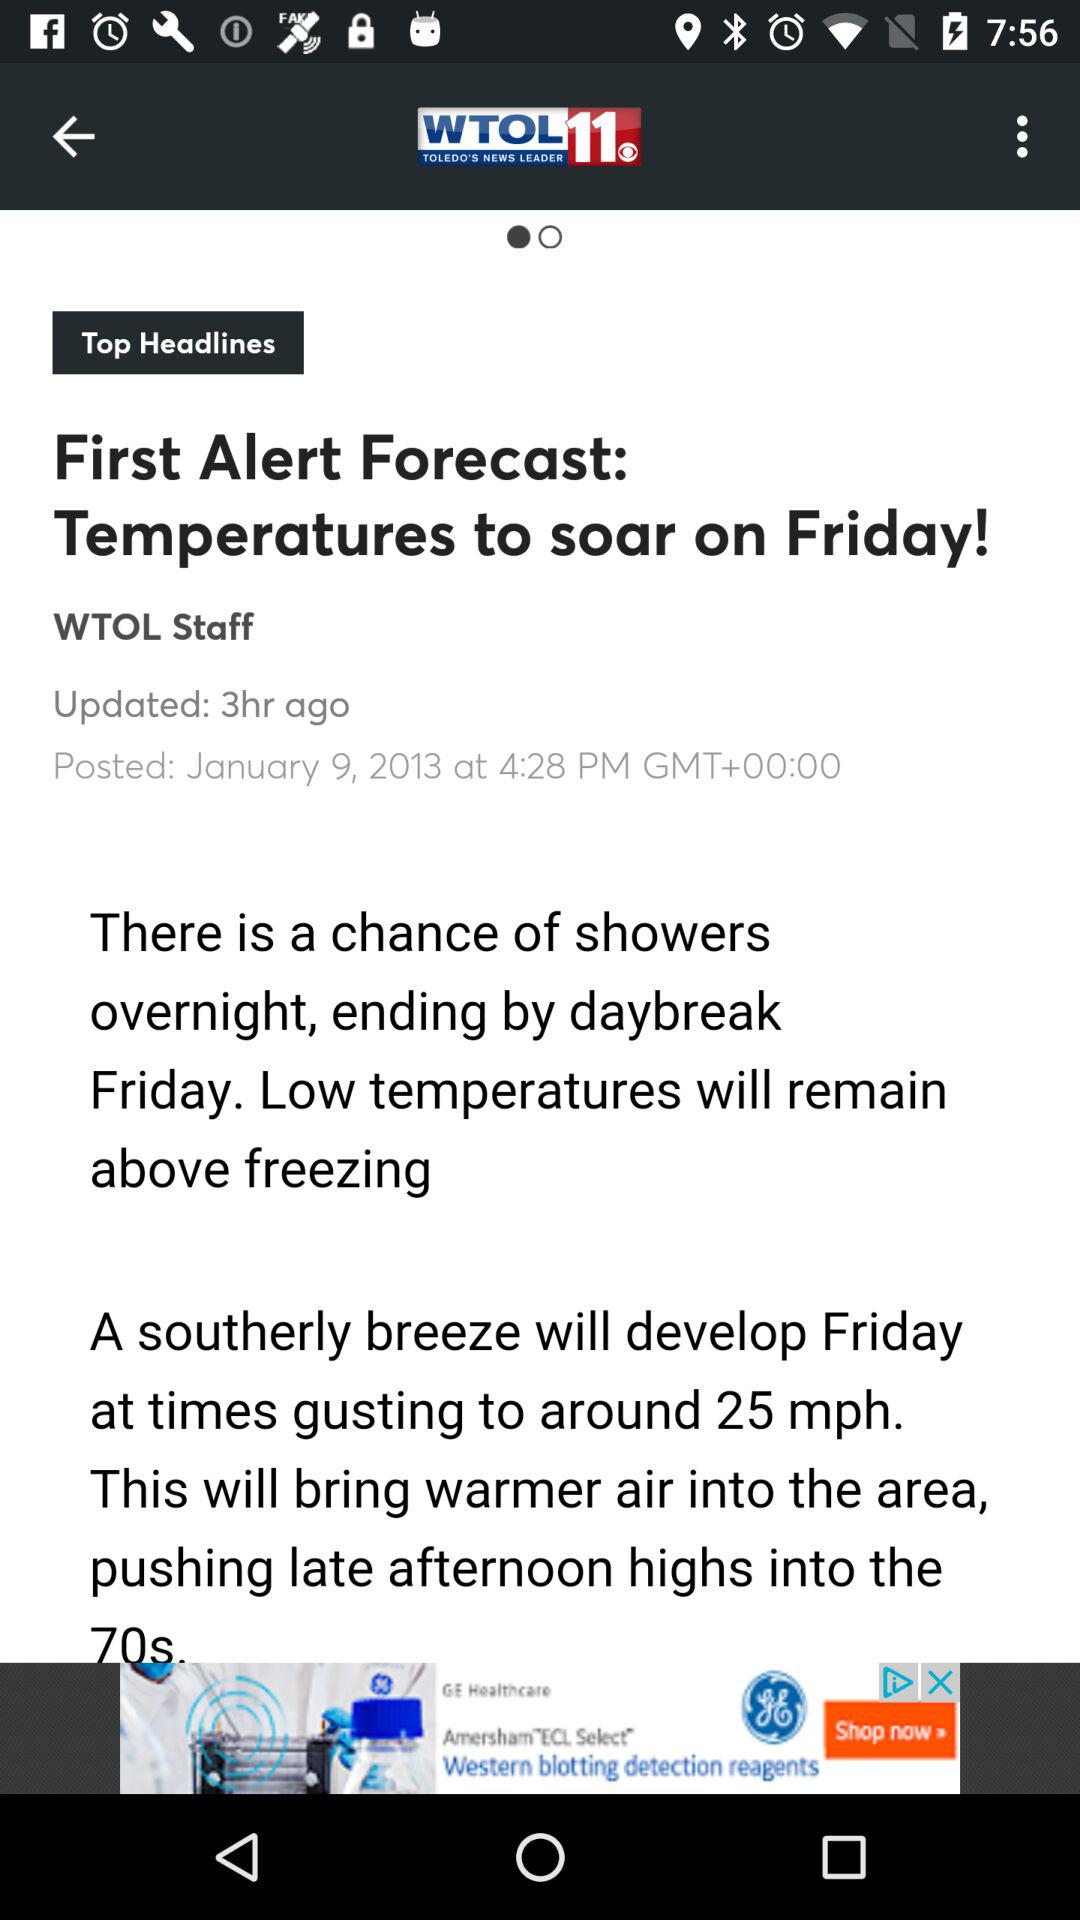Who posted the news? The news was posted by "WTOL Staff". 